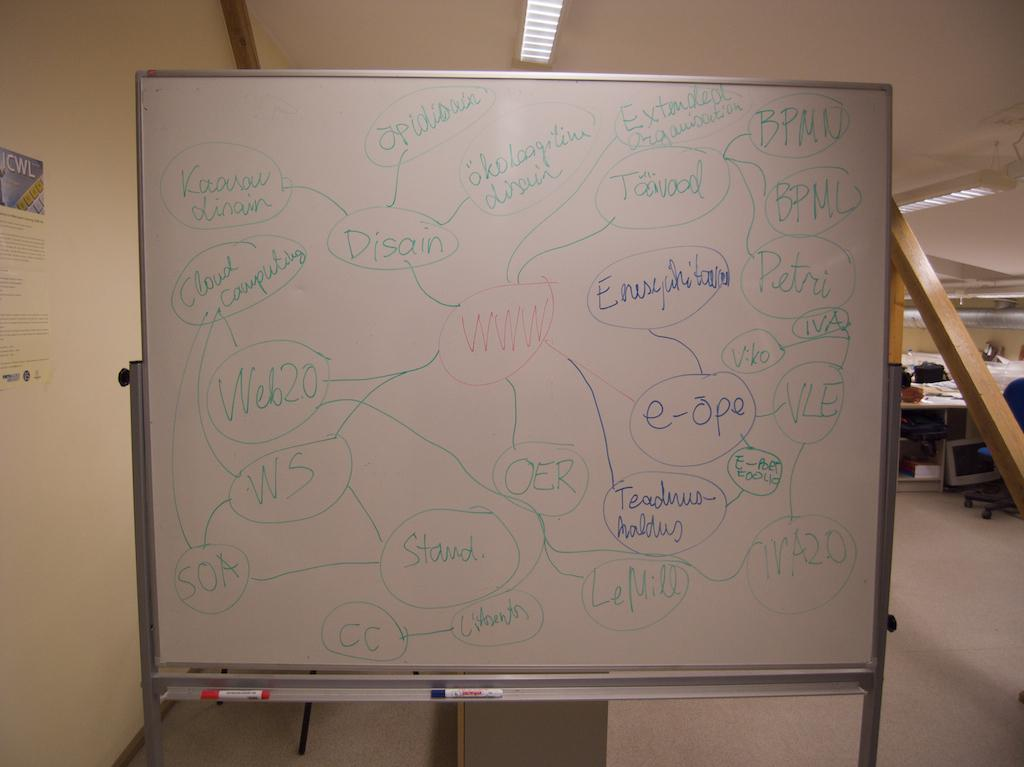<image>
Provide a brief description of the given image. A whiteboard with the letters "www" written in red 